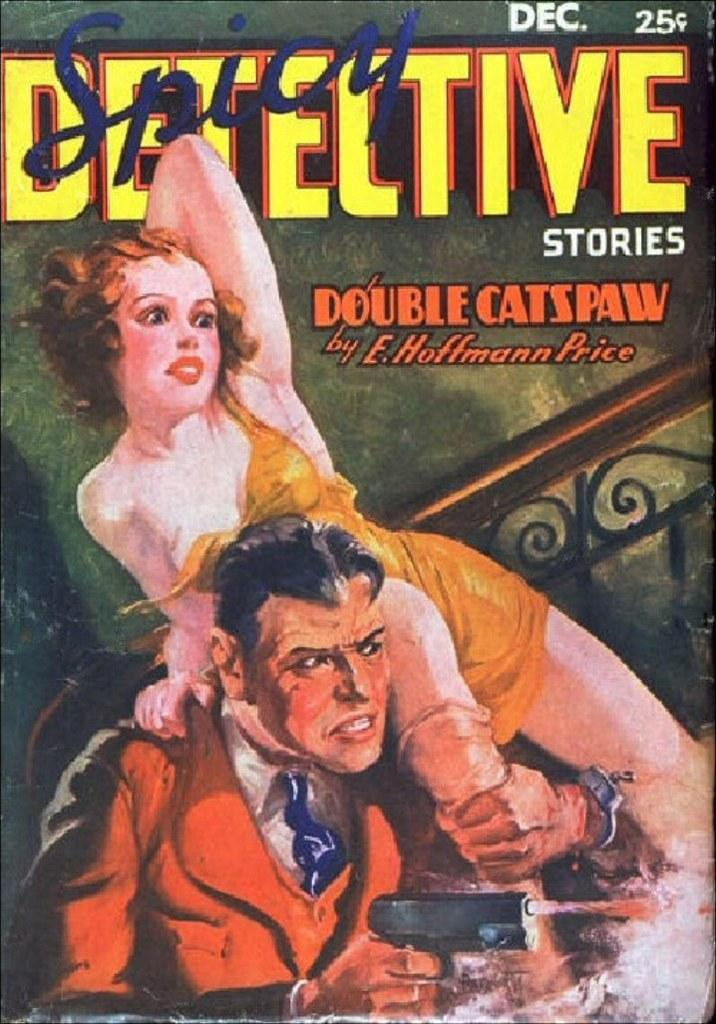Provide a one-sentence caption for the provided image. The cover of spicy detective stories by e hoffman price. 